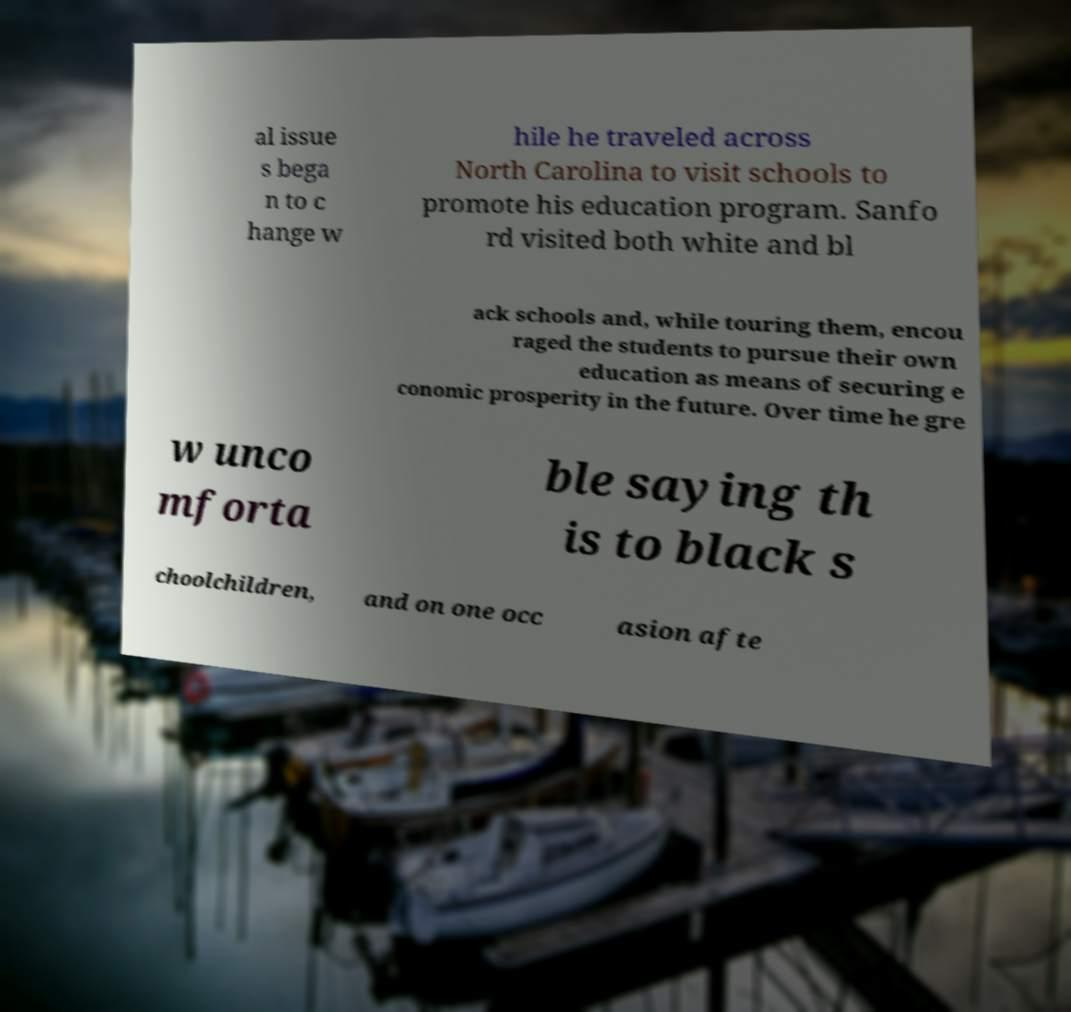I need the written content from this picture converted into text. Can you do that? al issue s bega n to c hange w hile he traveled across North Carolina to visit schools to promote his education program. Sanfo rd visited both white and bl ack schools and, while touring them, encou raged the students to pursue their own education as means of securing e conomic prosperity in the future. Over time he gre w unco mforta ble saying th is to black s choolchildren, and on one occ asion afte 